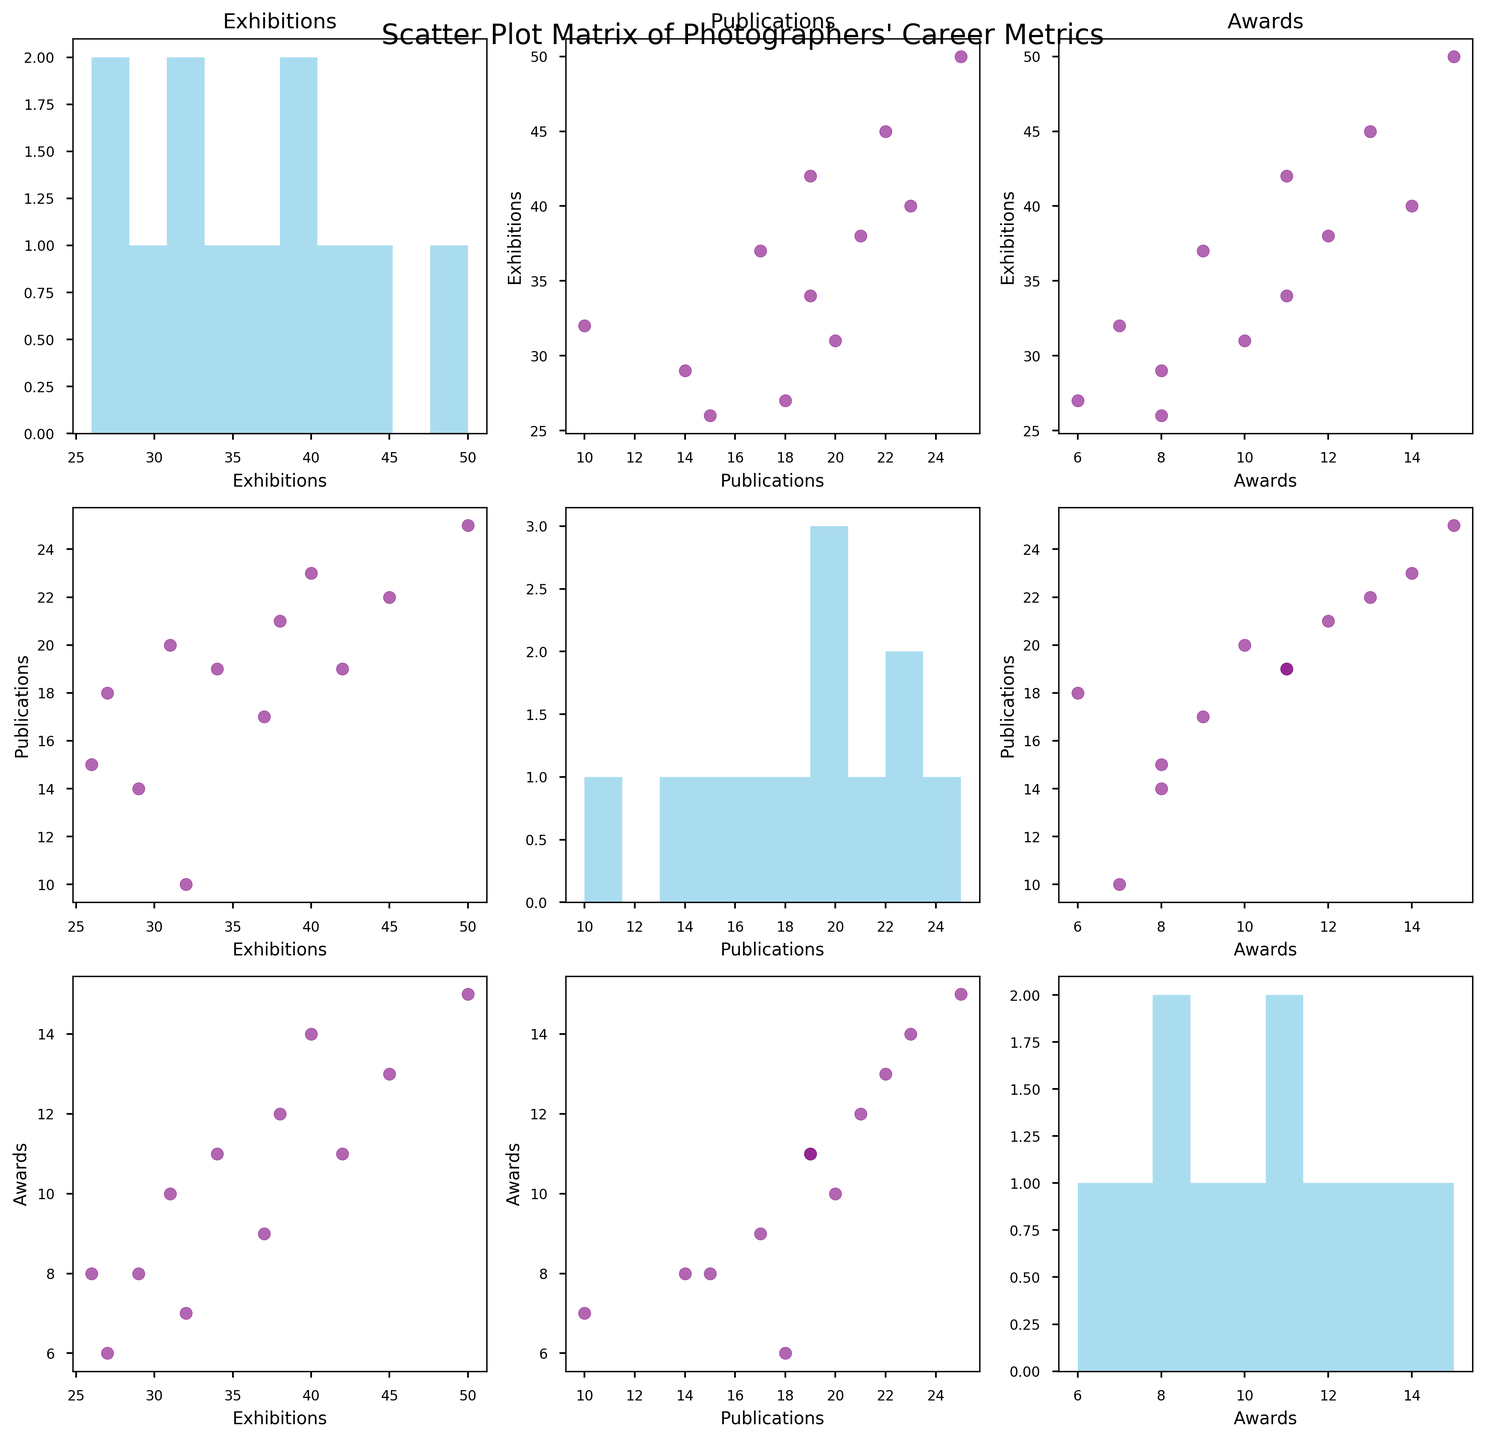How many axes are present in the scatter plot matrix? The figure has three features: Exhibitions, Publications, and Awards. A scatter plot matrix includes plots for every pair of features and diagonal histograms of each feature. Thus, the figure has 3x3 = 9 axes.
Answer: 9 What is the color of the scatter plot points? The scatter plot points are colored in a consistent purple shade across all scatter plots within the SPLOM.
Answer: Purple What is the axis label of the histogram in the second row and second column? The histogram in the second row and second column corresponds to the "Publications" feature. Thus, the axis label will be "Publications."
Answer: Publications Which photographer has the highest number of Exhibitions and how many do they have? Looking at the scatter plot matrix, Alfred Stieglitz has the highest number of Exhibitions, standing out in the 'Exhibitions' histogram. He has 50 Exhibitions.
Answer: Alfred Stieglitz, 50 How many photographers have more than 40 exhibitions? From the scatter plot data, four photographers have more than 40 exhibitions: Ansel Adams, Alfred Stieglitz, Margaret Bourke-White, and Man Ray.
Answer: 4 What's the average number of Awards received by the photographers? Summing up the Awards: 13 + 11 + 8 + 15 + 10 + 12 + 6 + 14 + 9 + 11 + 8 + 7 = 124. Dividing by the number of photographers (12) gives 124/12 = 10.33.
Answer: 10.33 Which two photographers have the closest number of Publications? By observing the data points in the scatter plots related to Publications, Dorothea Lange and Man Ray both have 19 publications, having the identical value.
Answer: Dorothea Lange and Man Ray Is there a visible trend or correlation between Exhibitions and Awards? Examining the scatter plots of Exhibitions vs. Awards, the points generally ascend to the right, indicating that photographers with more exhibitions tend to receive more awards, suggesting a positive correlation.
Answer: Positive correlation Based on the histograms, what is the most frequent number range of Publications among photographers? The histogram for "Publications" shows that the most frequent range is around 19-21, suggesting that many photographers in this dataset fall within this range for their publications count.
Answer: 19-21 